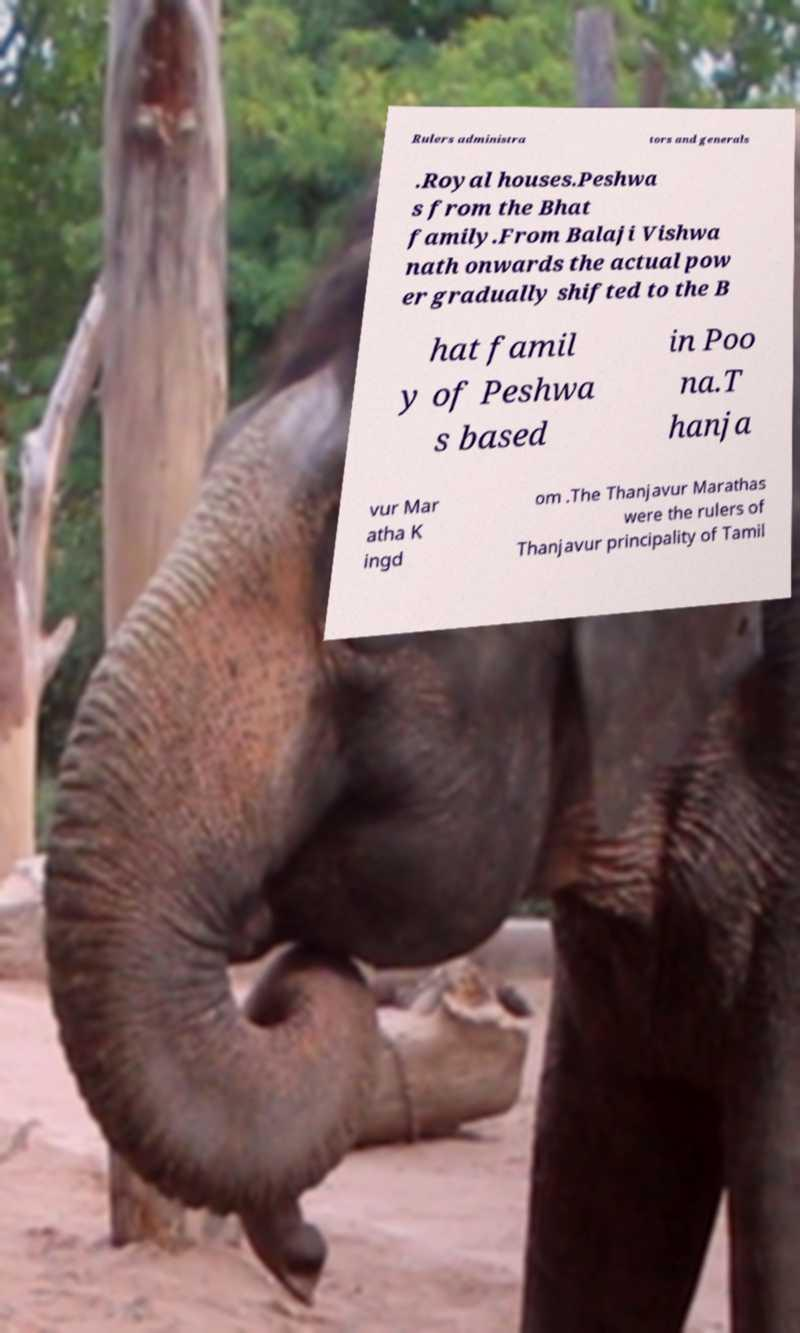Please read and relay the text visible in this image. What does it say? Rulers administra tors and generals .Royal houses.Peshwa s from the Bhat family.From Balaji Vishwa nath onwards the actual pow er gradually shifted to the B hat famil y of Peshwa s based in Poo na.T hanja vur Mar atha K ingd om .The Thanjavur Marathas were the rulers of Thanjavur principality of Tamil 